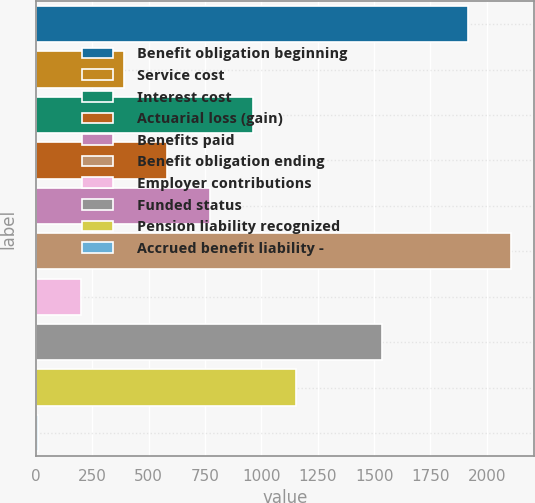<chart> <loc_0><loc_0><loc_500><loc_500><bar_chart><fcel>Benefit obligation beginning<fcel>Service cost<fcel>Interest cost<fcel>Actuarial loss (gain)<fcel>Benefits paid<fcel>Benefit obligation ending<fcel>Employer contributions<fcel>Funded status<fcel>Pension liability recognized<fcel>Accrued benefit liability -<nl><fcel>1916<fcel>390.4<fcel>962.5<fcel>581.1<fcel>771.8<fcel>2106.7<fcel>199.7<fcel>1534.6<fcel>1153.2<fcel>9<nl></chart> 